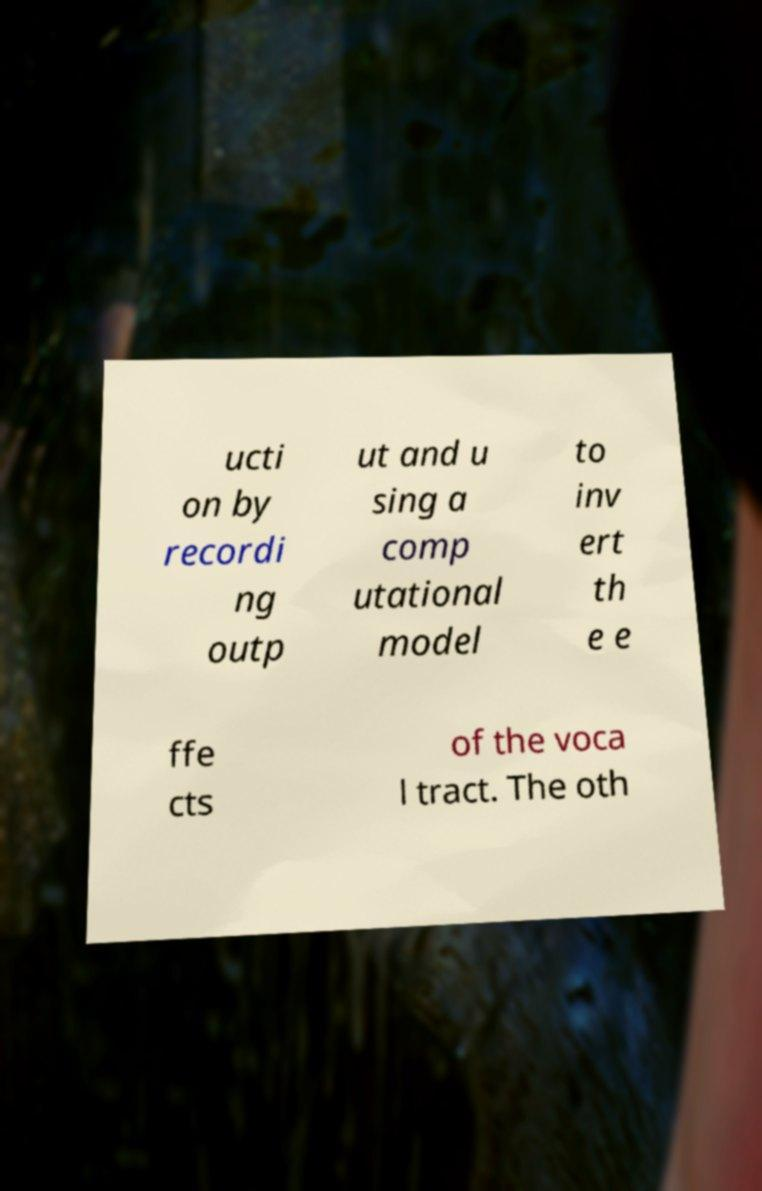There's text embedded in this image that I need extracted. Can you transcribe it verbatim? ucti on by recordi ng outp ut and u sing a comp utational model to inv ert th e e ffe cts of the voca l tract. The oth 